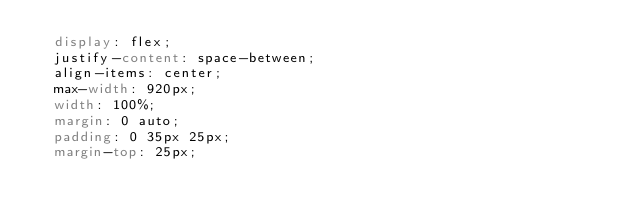<code> <loc_0><loc_0><loc_500><loc_500><_CSS_>  display: flex;
  justify-content: space-between;
  align-items: center;
  max-width: 920px;
  width: 100%;
  margin: 0 auto;
  padding: 0 35px 25px;
  margin-top: 25px;</code> 